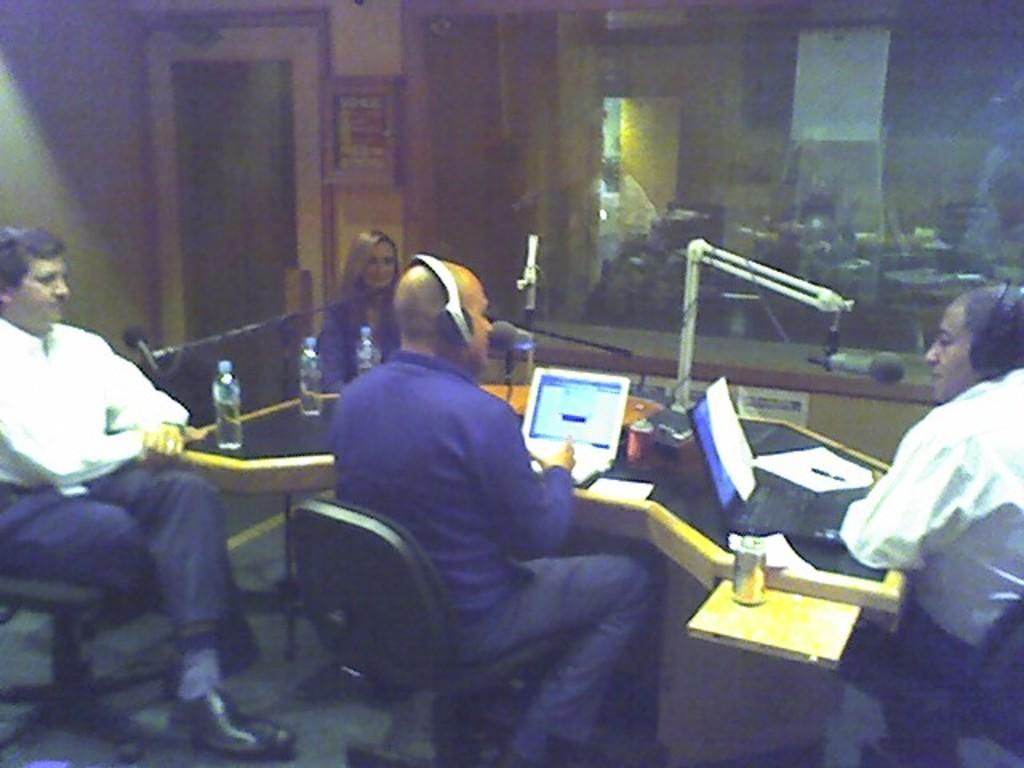Could you give a brief overview of what you see in this image? This picture shows few people seated on the chairs and we see couple of men wore headsets and we see couple of laptops on the table and few water bottles and couple of microphones. 